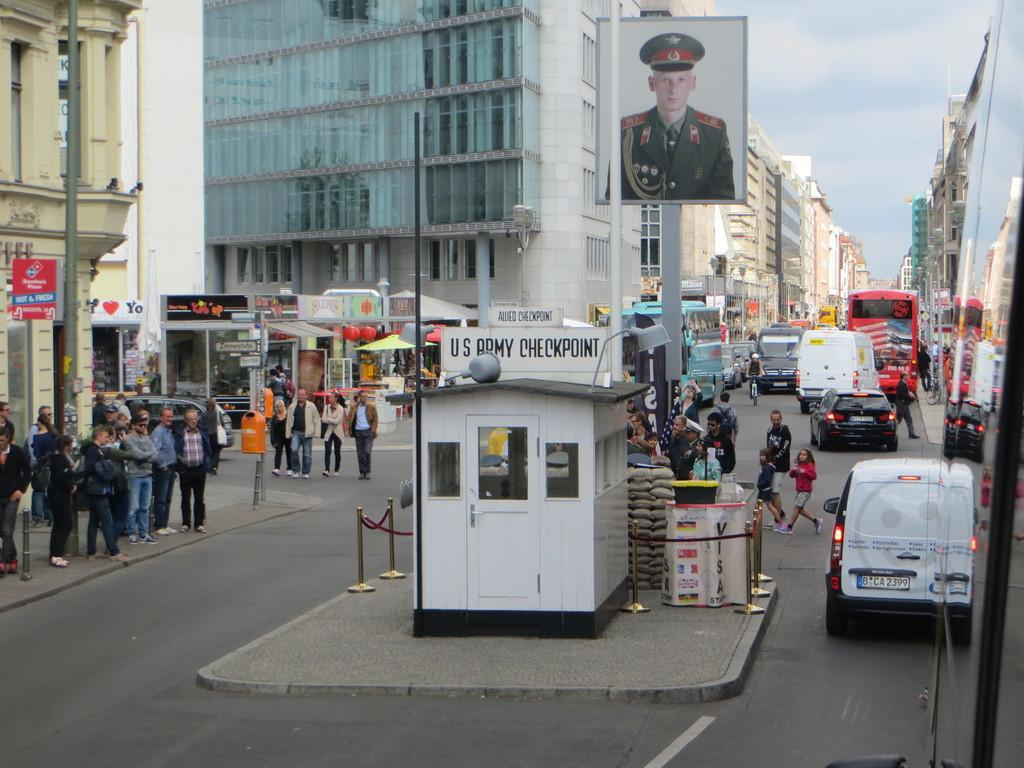What can be seen in the image in terms of structures? There are many buildings in the image. What is happening on the road in the image? There are people walking on the road and vehicles on the road. Can you describe the scene in the middle of the road? There is a board of a person in the middle of the road. What type of range can be seen in the image? There is no range present in the image. Is there a battle taking place in the image? There is no battle depicted in the image. 